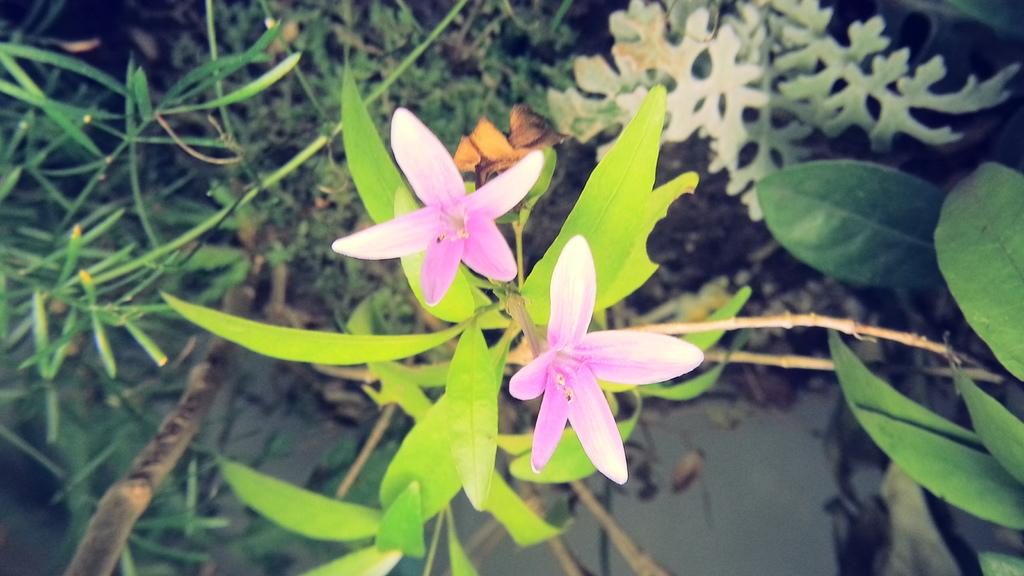Where was the image taken? The image is taken outdoors. What type of vegetation can be seen in the image? There are plants with green leaves and stems in the image. How many flowers are present in the image? There are two flowers in the image. What color are the flowers? The flowers are pink in color. What type of soap is being used to clean the snake in the image? There is no soap, snake, or cleaning activity present in the image. 